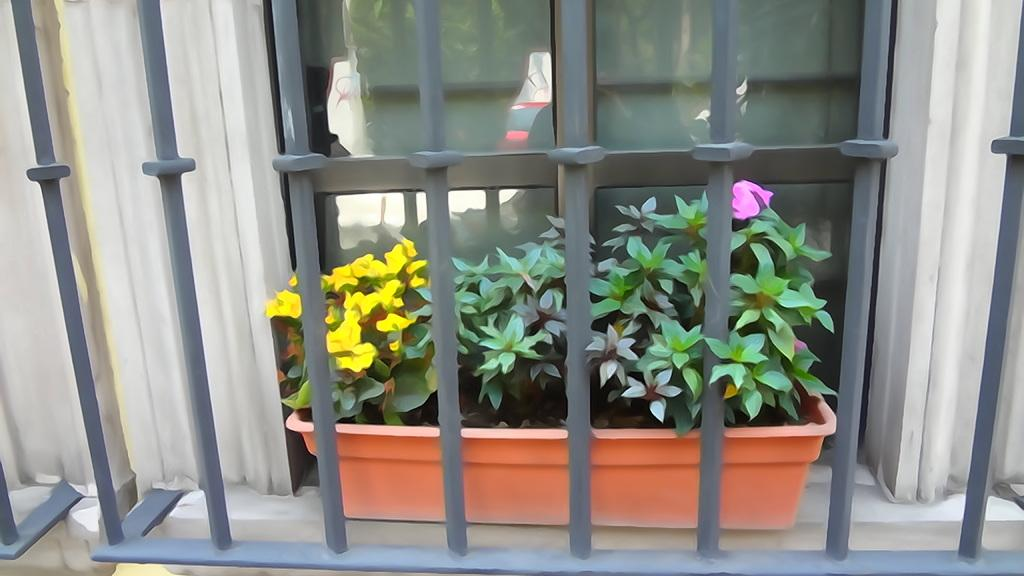What type of structure can be seen in the image? There is a fencing in the image. What is visible beyond the fencing? A plant is visible through the fencing. What type of architectural feature is present in the image? There is a glass window in the image. Can you see the eyes of the rabbit in the image? There is no rabbit or eyes present in the image. 